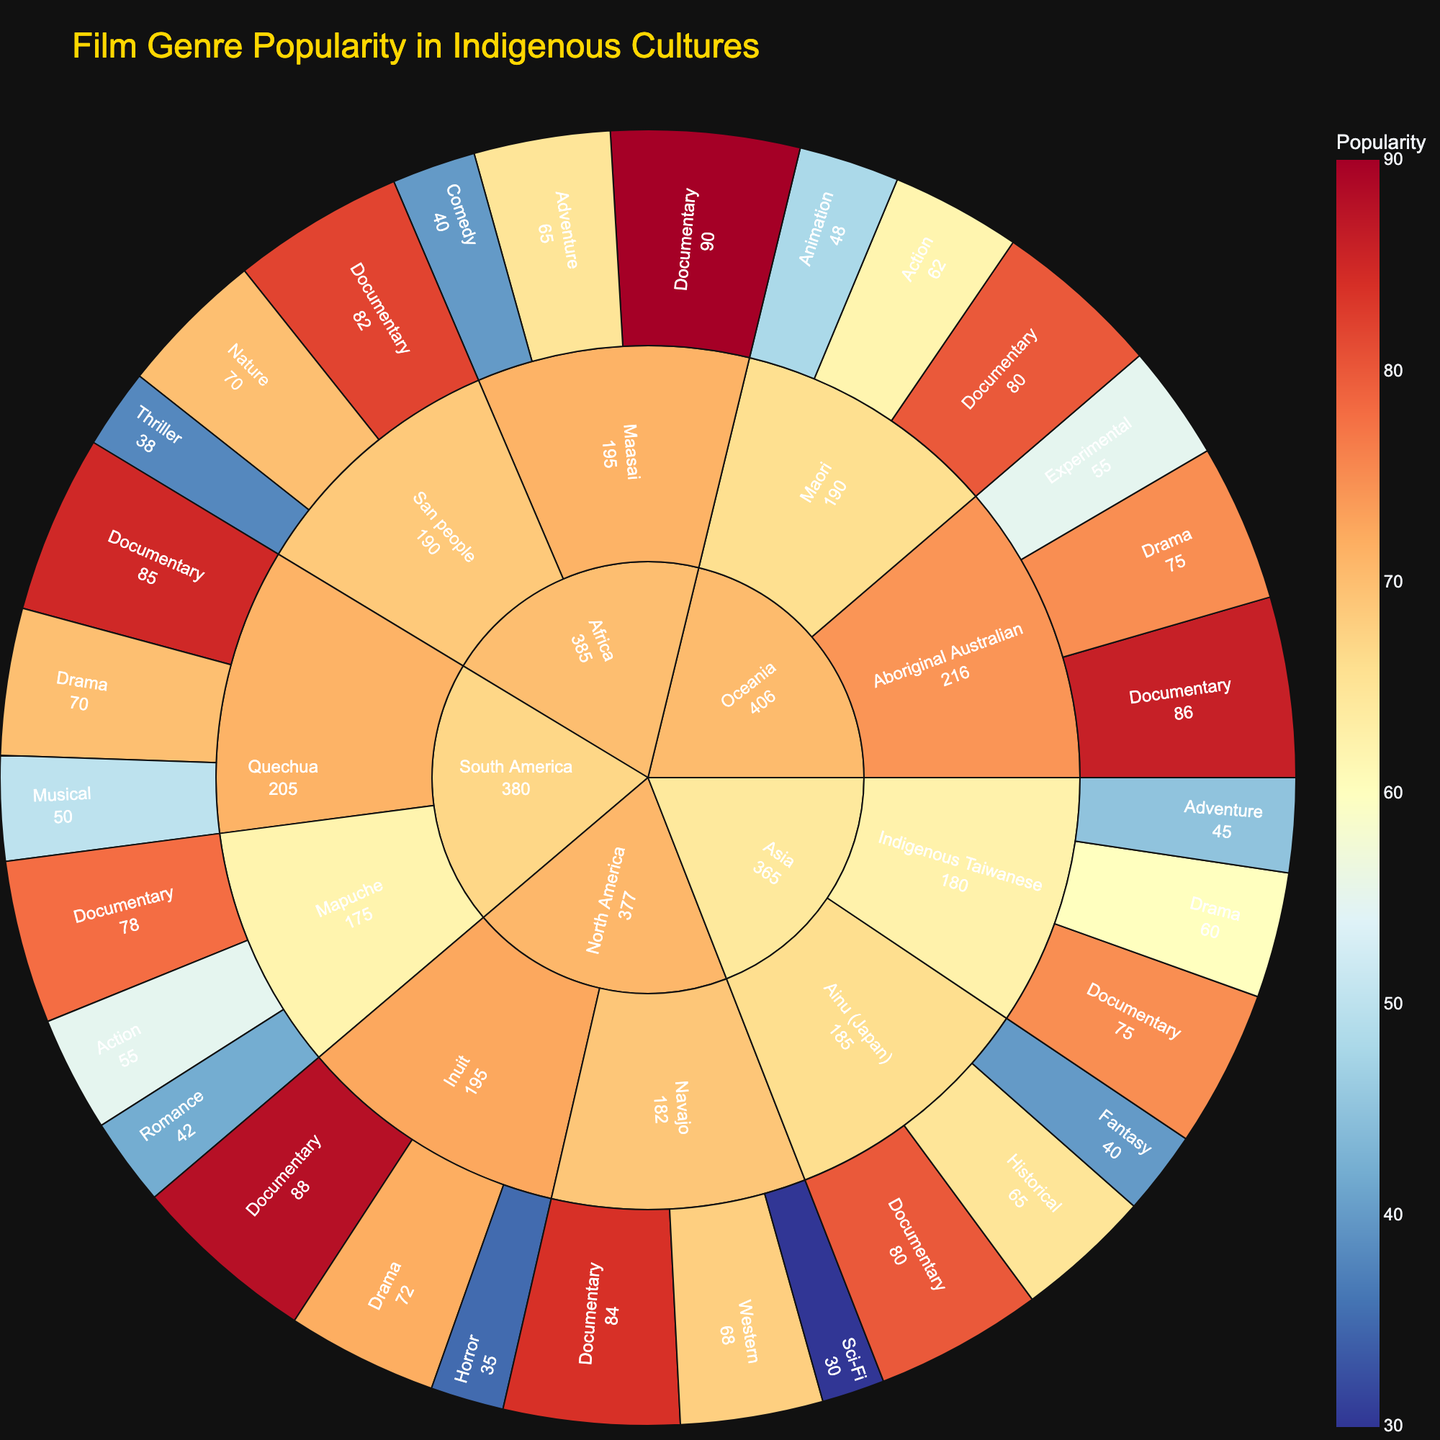What's the title of the plot? The title is usually found at the top of the plot, indicating what data it's visualizing.
Answer: Film Genre Popularity in Indigenous Cultures Which genre is most popular among the Maasai culture? To find this, look at the Maasai culture slice and identify the genre with the highest value in its category.
Answer: Documentary How does the popularity of Documentaries compare between the Indigenous Taiwanese and the Quechua cultures? Locate both categories for Indigenous Taiwanese and Quechua, then compare the heights or values of the Documentary genres. Indigenous Taiwanese has a value of 75, while Quechua has a value of 85.
Answer: Quechua Documentaries are more popular What’s the least popular genre for the Aboriginal Australian culture? Within the Aboriginal Australian slice, the genre with the smallest segment size represents the least popular genre.
Answer: Experimental Among the regions represented, which has the highest cumulative popularity for Documentary films? Sum up the popularity values of Documentary films across all cultural groups in each region, then compare these sums.
Answer: Africa (Maasai: 90 + San people: 82) Between Drama and Adventure, which genre has higher popularity in the Indigenous Taiwanese culture? Look at the Indigenous Taiwanese culture slice and compare the values for Drama (60) and Adventure (45).
Answer: Drama What region has the highest popularity for Horror films? Check all regions for any representations of Horror films and compare their popularity. North America’s Inuit has 35. None of the other regions have Horror films.
Answer: North America How many cultural groups prefer Adventure genre over Comedy? Identify the cultural groups that have Adventure and Comedy genres, then count those where Adventure values are higher. The Maasai (65) prefer Adventure over Comedy (40).
Answer: 1 What is the difference in popularity between Fantasy and Historical genres within the Ainu (Japan) culture? Find the values for Fantasy (40) and Historical (65) within the Ainu (Japan) culture and calculate their difference.
Answer: 25 What genre has the most consistent popularity across all cultures? Check the popularity of each genre in all cultures and determine which has the least variation in its values. Documentaries show consistently high values across all cultures.
Answer: Documentary 